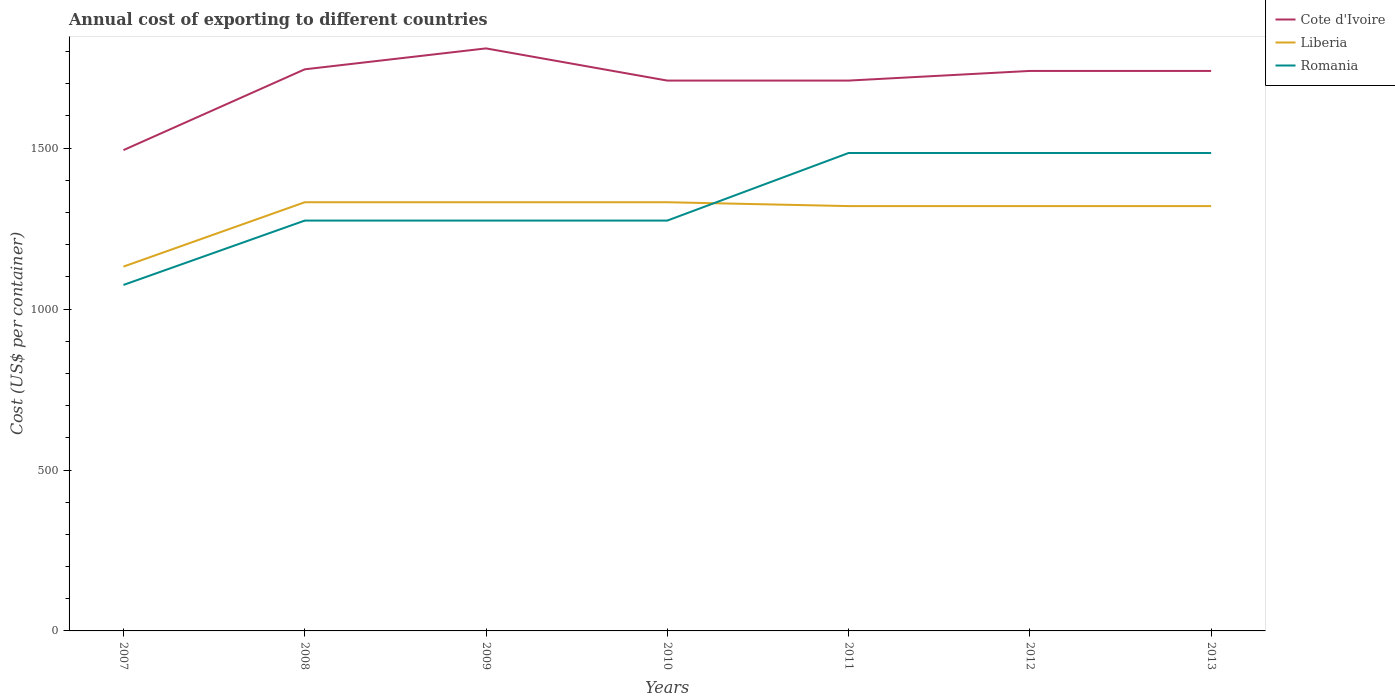How many different coloured lines are there?
Keep it short and to the point. 3. Does the line corresponding to Liberia intersect with the line corresponding to Romania?
Your response must be concise. Yes. Is the number of lines equal to the number of legend labels?
Your answer should be compact. Yes. Across all years, what is the maximum total annual cost of exporting in Liberia?
Keep it short and to the point. 1132. What is the total total annual cost of exporting in Liberia in the graph?
Provide a succinct answer. 0. What is the difference between the highest and the second highest total annual cost of exporting in Cote d'Ivoire?
Provide a succinct answer. 316. Is the total annual cost of exporting in Cote d'Ivoire strictly greater than the total annual cost of exporting in Liberia over the years?
Make the answer very short. No. How many lines are there?
Offer a very short reply. 3. How many years are there in the graph?
Make the answer very short. 7. What is the difference between two consecutive major ticks on the Y-axis?
Provide a succinct answer. 500. What is the title of the graph?
Your response must be concise. Annual cost of exporting to different countries. What is the label or title of the X-axis?
Your answer should be compact. Years. What is the label or title of the Y-axis?
Make the answer very short. Cost (US$ per container). What is the Cost (US$ per container) in Cote d'Ivoire in 2007?
Provide a succinct answer. 1494. What is the Cost (US$ per container) of Liberia in 2007?
Make the answer very short. 1132. What is the Cost (US$ per container) of Romania in 2007?
Provide a succinct answer. 1075. What is the Cost (US$ per container) in Cote d'Ivoire in 2008?
Provide a succinct answer. 1745. What is the Cost (US$ per container) in Liberia in 2008?
Offer a very short reply. 1332. What is the Cost (US$ per container) in Romania in 2008?
Give a very brief answer. 1275. What is the Cost (US$ per container) of Cote d'Ivoire in 2009?
Your answer should be very brief. 1810. What is the Cost (US$ per container) in Liberia in 2009?
Offer a very short reply. 1332. What is the Cost (US$ per container) of Romania in 2009?
Keep it short and to the point. 1275. What is the Cost (US$ per container) of Cote d'Ivoire in 2010?
Provide a succinct answer. 1710. What is the Cost (US$ per container) in Liberia in 2010?
Provide a succinct answer. 1332. What is the Cost (US$ per container) of Romania in 2010?
Your response must be concise. 1275. What is the Cost (US$ per container) of Cote d'Ivoire in 2011?
Your answer should be compact. 1710. What is the Cost (US$ per container) of Liberia in 2011?
Ensure brevity in your answer.  1320. What is the Cost (US$ per container) in Romania in 2011?
Your response must be concise. 1485. What is the Cost (US$ per container) in Cote d'Ivoire in 2012?
Offer a terse response. 1740. What is the Cost (US$ per container) in Liberia in 2012?
Provide a succinct answer. 1320. What is the Cost (US$ per container) of Romania in 2012?
Your answer should be compact. 1485. What is the Cost (US$ per container) in Cote d'Ivoire in 2013?
Provide a short and direct response. 1740. What is the Cost (US$ per container) in Liberia in 2013?
Keep it short and to the point. 1320. What is the Cost (US$ per container) of Romania in 2013?
Keep it short and to the point. 1485. Across all years, what is the maximum Cost (US$ per container) of Cote d'Ivoire?
Your answer should be very brief. 1810. Across all years, what is the maximum Cost (US$ per container) of Liberia?
Ensure brevity in your answer.  1332. Across all years, what is the maximum Cost (US$ per container) of Romania?
Give a very brief answer. 1485. Across all years, what is the minimum Cost (US$ per container) in Cote d'Ivoire?
Provide a succinct answer. 1494. Across all years, what is the minimum Cost (US$ per container) of Liberia?
Your answer should be compact. 1132. Across all years, what is the minimum Cost (US$ per container) in Romania?
Give a very brief answer. 1075. What is the total Cost (US$ per container) in Cote d'Ivoire in the graph?
Your response must be concise. 1.19e+04. What is the total Cost (US$ per container) in Liberia in the graph?
Provide a succinct answer. 9088. What is the total Cost (US$ per container) of Romania in the graph?
Keep it short and to the point. 9355. What is the difference between the Cost (US$ per container) in Cote d'Ivoire in 2007 and that in 2008?
Give a very brief answer. -251. What is the difference between the Cost (US$ per container) of Liberia in 2007 and that in 2008?
Provide a succinct answer. -200. What is the difference between the Cost (US$ per container) of Romania in 2007 and that in 2008?
Give a very brief answer. -200. What is the difference between the Cost (US$ per container) of Cote d'Ivoire in 2007 and that in 2009?
Your answer should be very brief. -316. What is the difference between the Cost (US$ per container) of Liberia in 2007 and that in 2009?
Provide a short and direct response. -200. What is the difference between the Cost (US$ per container) in Romania in 2007 and that in 2009?
Provide a succinct answer. -200. What is the difference between the Cost (US$ per container) in Cote d'Ivoire in 2007 and that in 2010?
Keep it short and to the point. -216. What is the difference between the Cost (US$ per container) in Liberia in 2007 and that in 2010?
Offer a very short reply. -200. What is the difference between the Cost (US$ per container) in Romania in 2007 and that in 2010?
Your answer should be very brief. -200. What is the difference between the Cost (US$ per container) in Cote d'Ivoire in 2007 and that in 2011?
Your answer should be compact. -216. What is the difference between the Cost (US$ per container) of Liberia in 2007 and that in 2011?
Make the answer very short. -188. What is the difference between the Cost (US$ per container) of Romania in 2007 and that in 2011?
Offer a terse response. -410. What is the difference between the Cost (US$ per container) in Cote d'Ivoire in 2007 and that in 2012?
Give a very brief answer. -246. What is the difference between the Cost (US$ per container) in Liberia in 2007 and that in 2012?
Provide a succinct answer. -188. What is the difference between the Cost (US$ per container) of Romania in 2007 and that in 2012?
Ensure brevity in your answer.  -410. What is the difference between the Cost (US$ per container) of Cote d'Ivoire in 2007 and that in 2013?
Provide a short and direct response. -246. What is the difference between the Cost (US$ per container) of Liberia in 2007 and that in 2013?
Provide a succinct answer. -188. What is the difference between the Cost (US$ per container) in Romania in 2007 and that in 2013?
Your answer should be very brief. -410. What is the difference between the Cost (US$ per container) in Cote d'Ivoire in 2008 and that in 2009?
Keep it short and to the point. -65. What is the difference between the Cost (US$ per container) of Liberia in 2008 and that in 2009?
Keep it short and to the point. 0. What is the difference between the Cost (US$ per container) in Romania in 2008 and that in 2009?
Your response must be concise. 0. What is the difference between the Cost (US$ per container) in Liberia in 2008 and that in 2010?
Your answer should be compact. 0. What is the difference between the Cost (US$ per container) of Cote d'Ivoire in 2008 and that in 2011?
Ensure brevity in your answer.  35. What is the difference between the Cost (US$ per container) of Liberia in 2008 and that in 2011?
Keep it short and to the point. 12. What is the difference between the Cost (US$ per container) in Romania in 2008 and that in 2011?
Ensure brevity in your answer.  -210. What is the difference between the Cost (US$ per container) in Liberia in 2008 and that in 2012?
Your answer should be compact. 12. What is the difference between the Cost (US$ per container) of Romania in 2008 and that in 2012?
Your answer should be very brief. -210. What is the difference between the Cost (US$ per container) of Cote d'Ivoire in 2008 and that in 2013?
Your answer should be very brief. 5. What is the difference between the Cost (US$ per container) in Romania in 2008 and that in 2013?
Your response must be concise. -210. What is the difference between the Cost (US$ per container) of Cote d'Ivoire in 2009 and that in 2010?
Offer a very short reply. 100. What is the difference between the Cost (US$ per container) in Romania in 2009 and that in 2010?
Provide a short and direct response. 0. What is the difference between the Cost (US$ per container) in Liberia in 2009 and that in 2011?
Provide a succinct answer. 12. What is the difference between the Cost (US$ per container) in Romania in 2009 and that in 2011?
Your answer should be very brief. -210. What is the difference between the Cost (US$ per container) in Cote d'Ivoire in 2009 and that in 2012?
Your answer should be very brief. 70. What is the difference between the Cost (US$ per container) of Romania in 2009 and that in 2012?
Your answer should be compact. -210. What is the difference between the Cost (US$ per container) in Cote d'Ivoire in 2009 and that in 2013?
Provide a short and direct response. 70. What is the difference between the Cost (US$ per container) of Romania in 2009 and that in 2013?
Provide a short and direct response. -210. What is the difference between the Cost (US$ per container) of Cote d'Ivoire in 2010 and that in 2011?
Make the answer very short. 0. What is the difference between the Cost (US$ per container) of Liberia in 2010 and that in 2011?
Your response must be concise. 12. What is the difference between the Cost (US$ per container) in Romania in 2010 and that in 2011?
Your answer should be very brief. -210. What is the difference between the Cost (US$ per container) of Liberia in 2010 and that in 2012?
Ensure brevity in your answer.  12. What is the difference between the Cost (US$ per container) of Romania in 2010 and that in 2012?
Provide a succinct answer. -210. What is the difference between the Cost (US$ per container) in Romania in 2010 and that in 2013?
Your answer should be very brief. -210. What is the difference between the Cost (US$ per container) of Cote d'Ivoire in 2011 and that in 2012?
Your answer should be compact. -30. What is the difference between the Cost (US$ per container) in Romania in 2011 and that in 2012?
Offer a very short reply. 0. What is the difference between the Cost (US$ per container) of Liberia in 2011 and that in 2013?
Provide a short and direct response. 0. What is the difference between the Cost (US$ per container) in Liberia in 2012 and that in 2013?
Your answer should be very brief. 0. What is the difference between the Cost (US$ per container) in Romania in 2012 and that in 2013?
Ensure brevity in your answer.  0. What is the difference between the Cost (US$ per container) of Cote d'Ivoire in 2007 and the Cost (US$ per container) of Liberia in 2008?
Offer a very short reply. 162. What is the difference between the Cost (US$ per container) in Cote d'Ivoire in 2007 and the Cost (US$ per container) in Romania in 2008?
Offer a very short reply. 219. What is the difference between the Cost (US$ per container) of Liberia in 2007 and the Cost (US$ per container) of Romania in 2008?
Your response must be concise. -143. What is the difference between the Cost (US$ per container) of Cote d'Ivoire in 2007 and the Cost (US$ per container) of Liberia in 2009?
Offer a very short reply. 162. What is the difference between the Cost (US$ per container) of Cote d'Ivoire in 2007 and the Cost (US$ per container) of Romania in 2009?
Provide a succinct answer. 219. What is the difference between the Cost (US$ per container) of Liberia in 2007 and the Cost (US$ per container) of Romania in 2009?
Make the answer very short. -143. What is the difference between the Cost (US$ per container) in Cote d'Ivoire in 2007 and the Cost (US$ per container) in Liberia in 2010?
Keep it short and to the point. 162. What is the difference between the Cost (US$ per container) in Cote d'Ivoire in 2007 and the Cost (US$ per container) in Romania in 2010?
Give a very brief answer. 219. What is the difference between the Cost (US$ per container) of Liberia in 2007 and the Cost (US$ per container) of Romania in 2010?
Provide a short and direct response. -143. What is the difference between the Cost (US$ per container) in Cote d'Ivoire in 2007 and the Cost (US$ per container) in Liberia in 2011?
Your answer should be very brief. 174. What is the difference between the Cost (US$ per container) in Liberia in 2007 and the Cost (US$ per container) in Romania in 2011?
Offer a very short reply. -353. What is the difference between the Cost (US$ per container) in Cote d'Ivoire in 2007 and the Cost (US$ per container) in Liberia in 2012?
Your response must be concise. 174. What is the difference between the Cost (US$ per container) of Liberia in 2007 and the Cost (US$ per container) of Romania in 2012?
Provide a short and direct response. -353. What is the difference between the Cost (US$ per container) of Cote d'Ivoire in 2007 and the Cost (US$ per container) of Liberia in 2013?
Your answer should be very brief. 174. What is the difference between the Cost (US$ per container) in Cote d'Ivoire in 2007 and the Cost (US$ per container) in Romania in 2013?
Your answer should be very brief. 9. What is the difference between the Cost (US$ per container) in Liberia in 2007 and the Cost (US$ per container) in Romania in 2013?
Give a very brief answer. -353. What is the difference between the Cost (US$ per container) of Cote d'Ivoire in 2008 and the Cost (US$ per container) of Liberia in 2009?
Your answer should be compact. 413. What is the difference between the Cost (US$ per container) of Cote d'Ivoire in 2008 and the Cost (US$ per container) of Romania in 2009?
Your response must be concise. 470. What is the difference between the Cost (US$ per container) in Liberia in 2008 and the Cost (US$ per container) in Romania in 2009?
Make the answer very short. 57. What is the difference between the Cost (US$ per container) of Cote d'Ivoire in 2008 and the Cost (US$ per container) of Liberia in 2010?
Ensure brevity in your answer.  413. What is the difference between the Cost (US$ per container) of Cote d'Ivoire in 2008 and the Cost (US$ per container) of Romania in 2010?
Keep it short and to the point. 470. What is the difference between the Cost (US$ per container) in Cote d'Ivoire in 2008 and the Cost (US$ per container) in Liberia in 2011?
Your answer should be compact. 425. What is the difference between the Cost (US$ per container) of Cote d'Ivoire in 2008 and the Cost (US$ per container) of Romania in 2011?
Provide a succinct answer. 260. What is the difference between the Cost (US$ per container) in Liberia in 2008 and the Cost (US$ per container) in Romania in 2011?
Your answer should be very brief. -153. What is the difference between the Cost (US$ per container) of Cote d'Ivoire in 2008 and the Cost (US$ per container) of Liberia in 2012?
Offer a terse response. 425. What is the difference between the Cost (US$ per container) in Cote d'Ivoire in 2008 and the Cost (US$ per container) in Romania in 2012?
Provide a succinct answer. 260. What is the difference between the Cost (US$ per container) of Liberia in 2008 and the Cost (US$ per container) of Romania in 2012?
Offer a very short reply. -153. What is the difference between the Cost (US$ per container) in Cote d'Ivoire in 2008 and the Cost (US$ per container) in Liberia in 2013?
Keep it short and to the point. 425. What is the difference between the Cost (US$ per container) of Cote d'Ivoire in 2008 and the Cost (US$ per container) of Romania in 2013?
Keep it short and to the point. 260. What is the difference between the Cost (US$ per container) in Liberia in 2008 and the Cost (US$ per container) in Romania in 2013?
Make the answer very short. -153. What is the difference between the Cost (US$ per container) in Cote d'Ivoire in 2009 and the Cost (US$ per container) in Liberia in 2010?
Provide a short and direct response. 478. What is the difference between the Cost (US$ per container) in Cote d'Ivoire in 2009 and the Cost (US$ per container) in Romania in 2010?
Offer a terse response. 535. What is the difference between the Cost (US$ per container) in Cote d'Ivoire in 2009 and the Cost (US$ per container) in Liberia in 2011?
Provide a succinct answer. 490. What is the difference between the Cost (US$ per container) of Cote d'Ivoire in 2009 and the Cost (US$ per container) of Romania in 2011?
Offer a very short reply. 325. What is the difference between the Cost (US$ per container) of Liberia in 2009 and the Cost (US$ per container) of Romania in 2011?
Keep it short and to the point. -153. What is the difference between the Cost (US$ per container) in Cote d'Ivoire in 2009 and the Cost (US$ per container) in Liberia in 2012?
Give a very brief answer. 490. What is the difference between the Cost (US$ per container) in Cote d'Ivoire in 2009 and the Cost (US$ per container) in Romania in 2012?
Your response must be concise. 325. What is the difference between the Cost (US$ per container) of Liberia in 2009 and the Cost (US$ per container) of Romania in 2012?
Offer a terse response. -153. What is the difference between the Cost (US$ per container) of Cote d'Ivoire in 2009 and the Cost (US$ per container) of Liberia in 2013?
Your answer should be very brief. 490. What is the difference between the Cost (US$ per container) in Cote d'Ivoire in 2009 and the Cost (US$ per container) in Romania in 2013?
Keep it short and to the point. 325. What is the difference between the Cost (US$ per container) of Liberia in 2009 and the Cost (US$ per container) of Romania in 2013?
Your response must be concise. -153. What is the difference between the Cost (US$ per container) in Cote d'Ivoire in 2010 and the Cost (US$ per container) in Liberia in 2011?
Give a very brief answer. 390. What is the difference between the Cost (US$ per container) in Cote d'Ivoire in 2010 and the Cost (US$ per container) in Romania in 2011?
Your response must be concise. 225. What is the difference between the Cost (US$ per container) in Liberia in 2010 and the Cost (US$ per container) in Romania in 2011?
Keep it short and to the point. -153. What is the difference between the Cost (US$ per container) of Cote d'Ivoire in 2010 and the Cost (US$ per container) of Liberia in 2012?
Provide a succinct answer. 390. What is the difference between the Cost (US$ per container) of Cote d'Ivoire in 2010 and the Cost (US$ per container) of Romania in 2012?
Give a very brief answer. 225. What is the difference between the Cost (US$ per container) in Liberia in 2010 and the Cost (US$ per container) in Romania in 2012?
Your answer should be very brief. -153. What is the difference between the Cost (US$ per container) in Cote d'Ivoire in 2010 and the Cost (US$ per container) in Liberia in 2013?
Keep it short and to the point. 390. What is the difference between the Cost (US$ per container) in Cote d'Ivoire in 2010 and the Cost (US$ per container) in Romania in 2013?
Your answer should be compact. 225. What is the difference between the Cost (US$ per container) of Liberia in 2010 and the Cost (US$ per container) of Romania in 2013?
Your response must be concise. -153. What is the difference between the Cost (US$ per container) in Cote d'Ivoire in 2011 and the Cost (US$ per container) in Liberia in 2012?
Ensure brevity in your answer.  390. What is the difference between the Cost (US$ per container) of Cote d'Ivoire in 2011 and the Cost (US$ per container) of Romania in 2012?
Keep it short and to the point. 225. What is the difference between the Cost (US$ per container) in Liberia in 2011 and the Cost (US$ per container) in Romania in 2012?
Ensure brevity in your answer.  -165. What is the difference between the Cost (US$ per container) of Cote d'Ivoire in 2011 and the Cost (US$ per container) of Liberia in 2013?
Offer a terse response. 390. What is the difference between the Cost (US$ per container) of Cote d'Ivoire in 2011 and the Cost (US$ per container) of Romania in 2013?
Offer a very short reply. 225. What is the difference between the Cost (US$ per container) in Liberia in 2011 and the Cost (US$ per container) in Romania in 2013?
Offer a very short reply. -165. What is the difference between the Cost (US$ per container) in Cote d'Ivoire in 2012 and the Cost (US$ per container) in Liberia in 2013?
Provide a succinct answer. 420. What is the difference between the Cost (US$ per container) in Cote d'Ivoire in 2012 and the Cost (US$ per container) in Romania in 2013?
Your answer should be very brief. 255. What is the difference between the Cost (US$ per container) of Liberia in 2012 and the Cost (US$ per container) of Romania in 2013?
Offer a terse response. -165. What is the average Cost (US$ per container) in Cote d'Ivoire per year?
Offer a terse response. 1707. What is the average Cost (US$ per container) of Liberia per year?
Make the answer very short. 1298.29. What is the average Cost (US$ per container) of Romania per year?
Provide a succinct answer. 1336.43. In the year 2007, what is the difference between the Cost (US$ per container) in Cote d'Ivoire and Cost (US$ per container) in Liberia?
Keep it short and to the point. 362. In the year 2007, what is the difference between the Cost (US$ per container) of Cote d'Ivoire and Cost (US$ per container) of Romania?
Make the answer very short. 419. In the year 2008, what is the difference between the Cost (US$ per container) in Cote d'Ivoire and Cost (US$ per container) in Liberia?
Provide a succinct answer. 413. In the year 2008, what is the difference between the Cost (US$ per container) of Cote d'Ivoire and Cost (US$ per container) of Romania?
Your answer should be compact. 470. In the year 2009, what is the difference between the Cost (US$ per container) of Cote d'Ivoire and Cost (US$ per container) of Liberia?
Your answer should be very brief. 478. In the year 2009, what is the difference between the Cost (US$ per container) of Cote d'Ivoire and Cost (US$ per container) of Romania?
Provide a succinct answer. 535. In the year 2010, what is the difference between the Cost (US$ per container) of Cote d'Ivoire and Cost (US$ per container) of Liberia?
Provide a short and direct response. 378. In the year 2010, what is the difference between the Cost (US$ per container) in Cote d'Ivoire and Cost (US$ per container) in Romania?
Ensure brevity in your answer.  435. In the year 2011, what is the difference between the Cost (US$ per container) in Cote d'Ivoire and Cost (US$ per container) in Liberia?
Your answer should be compact. 390. In the year 2011, what is the difference between the Cost (US$ per container) in Cote d'Ivoire and Cost (US$ per container) in Romania?
Provide a short and direct response. 225. In the year 2011, what is the difference between the Cost (US$ per container) in Liberia and Cost (US$ per container) in Romania?
Keep it short and to the point. -165. In the year 2012, what is the difference between the Cost (US$ per container) of Cote d'Ivoire and Cost (US$ per container) of Liberia?
Provide a short and direct response. 420. In the year 2012, what is the difference between the Cost (US$ per container) of Cote d'Ivoire and Cost (US$ per container) of Romania?
Provide a succinct answer. 255. In the year 2012, what is the difference between the Cost (US$ per container) in Liberia and Cost (US$ per container) in Romania?
Your answer should be very brief. -165. In the year 2013, what is the difference between the Cost (US$ per container) in Cote d'Ivoire and Cost (US$ per container) in Liberia?
Provide a short and direct response. 420. In the year 2013, what is the difference between the Cost (US$ per container) of Cote d'Ivoire and Cost (US$ per container) of Romania?
Your answer should be compact. 255. In the year 2013, what is the difference between the Cost (US$ per container) in Liberia and Cost (US$ per container) in Romania?
Your answer should be compact. -165. What is the ratio of the Cost (US$ per container) of Cote d'Ivoire in 2007 to that in 2008?
Keep it short and to the point. 0.86. What is the ratio of the Cost (US$ per container) of Liberia in 2007 to that in 2008?
Ensure brevity in your answer.  0.85. What is the ratio of the Cost (US$ per container) in Romania in 2007 to that in 2008?
Provide a succinct answer. 0.84. What is the ratio of the Cost (US$ per container) of Cote d'Ivoire in 2007 to that in 2009?
Provide a succinct answer. 0.83. What is the ratio of the Cost (US$ per container) of Liberia in 2007 to that in 2009?
Provide a short and direct response. 0.85. What is the ratio of the Cost (US$ per container) in Romania in 2007 to that in 2009?
Your answer should be compact. 0.84. What is the ratio of the Cost (US$ per container) in Cote d'Ivoire in 2007 to that in 2010?
Offer a terse response. 0.87. What is the ratio of the Cost (US$ per container) in Liberia in 2007 to that in 2010?
Your answer should be very brief. 0.85. What is the ratio of the Cost (US$ per container) of Romania in 2007 to that in 2010?
Provide a succinct answer. 0.84. What is the ratio of the Cost (US$ per container) of Cote d'Ivoire in 2007 to that in 2011?
Your answer should be compact. 0.87. What is the ratio of the Cost (US$ per container) of Liberia in 2007 to that in 2011?
Keep it short and to the point. 0.86. What is the ratio of the Cost (US$ per container) of Romania in 2007 to that in 2011?
Give a very brief answer. 0.72. What is the ratio of the Cost (US$ per container) in Cote d'Ivoire in 2007 to that in 2012?
Your answer should be compact. 0.86. What is the ratio of the Cost (US$ per container) of Liberia in 2007 to that in 2012?
Keep it short and to the point. 0.86. What is the ratio of the Cost (US$ per container) of Romania in 2007 to that in 2012?
Your answer should be compact. 0.72. What is the ratio of the Cost (US$ per container) of Cote d'Ivoire in 2007 to that in 2013?
Keep it short and to the point. 0.86. What is the ratio of the Cost (US$ per container) in Liberia in 2007 to that in 2013?
Make the answer very short. 0.86. What is the ratio of the Cost (US$ per container) in Romania in 2007 to that in 2013?
Give a very brief answer. 0.72. What is the ratio of the Cost (US$ per container) of Cote d'Ivoire in 2008 to that in 2009?
Your answer should be compact. 0.96. What is the ratio of the Cost (US$ per container) of Liberia in 2008 to that in 2009?
Ensure brevity in your answer.  1. What is the ratio of the Cost (US$ per container) of Cote d'Ivoire in 2008 to that in 2010?
Keep it short and to the point. 1.02. What is the ratio of the Cost (US$ per container) of Romania in 2008 to that in 2010?
Provide a succinct answer. 1. What is the ratio of the Cost (US$ per container) of Cote d'Ivoire in 2008 to that in 2011?
Provide a short and direct response. 1.02. What is the ratio of the Cost (US$ per container) in Liberia in 2008 to that in 2011?
Your response must be concise. 1.01. What is the ratio of the Cost (US$ per container) of Romania in 2008 to that in 2011?
Your response must be concise. 0.86. What is the ratio of the Cost (US$ per container) in Cote d'Ivoire in 2008 to that in 2012?
Offer a terse response. 1. What is the ratio of the Cost (US$ per container) of Liberia in 2008 to that in 2012?
Ensure brevity in your answer.  1.01. What is the ratio of the Cost (US$ per container) in Romania in 2008 to that in 2012?
Offer a terse response. 0.86. What is the ratio of the Cost (US$ per container) in Liberia in 2008 to that in 2013?
Offer a very short reply. 1.01. What is the ratio of the Cost (US$ per container) in Romania in 2008 to that in 2013?
Provide a succinct answer. 0.86. What is the ratio of the Cost (US$ per container) in Cote d'Ivoire in 2009 to that in 2010?
Ensure brevity in your answer.  1.06. What is the ratio of the Cost (US$ per container) of Cote d'Ivoire in 2009 to that in 2011?
Your answer should be very brief. 1.06. What is the ratio of the Cost (US$ per container) in Liberia in 2009 to that in 2011?
Give a very brief answer. 1.01. What is the ratio of the Cost (US$ per container) in Romania in 2009 to that in 2011?
Your answer should be compact. 0.86. What is the ratio of the Cost (US$ per container) in Cote d'Ivoire in 2009 to that in 2012?
Offer a terse response. 1.04. What is the ratio of the Cost (US$ per container) in Liberia in 2009 to that in 2012?
Provide a short and direct response. 1.01. What is the ratio of the Cost (US$ per container) of Romania in 2009 to that in 2012?
Provide a succinct answer. 0.86. What is the ratio of the Cost (US$ per container) of Cote d'Ivoire in 2009 to that in 2013?
Your response must be concise. 1.04. What is the ratio of the Cost (US$ per container) of Liberia in 2009 to that in 2013?
Make the answer very short. 1.01. What is the ratio of the Cost (US$ per container) of Romania in 2009 to that in 2013?
Offer a very short reply. 0.86. What is the ratio of the Cost (US$ per container) of Liberia in 2010 to that in 2011?
Offer a terse response. 1.01. What is the ratio of the Cost (US$ per container) of Romania in 2010 to that in 2011?
Your answer should be compact. 0.86. What is the ratio of the Cost (US$ per container) in Cote d'Ivoire in 2010 to that in 2012?
Offer a terse response. 0.98. What is the ratio of the Cost (US$ per container) in Liberia in 2010 to that in 2012?
Your response must be concise. 1.01. What is the ratio of the Cost (US$ per container) in Romania in 2010 to that in 2012?
Your response must be concise. 0.86. What is the ratio of the Cost (US$ per container) of Cote d'Ivoire in 2010 to that in 2013?
Keep it short and to the point. 0.98. What is the ratio of the Cost (US$ per container) in Liberia in 2010 to that in 2013?
Offer a very short reply. 1.01. What is the ratio of the Cost (US$ per container) of Romania in 2010 to that in 2013?
Offer a terse response. 0.86. What is the ratio of the Cost (US$ per container) in Cote d'Ivoire in 2011 to that in 2012?
Keep it short and to the point. 0.98. What is the ratio of the Cost (US$ per container) of Liberia in 2011 to that in 2012?
Your answer should be very brief. 1. What is the ratio of the Cost (US$ per container) in Cote d'Ivoire in 2011 to that in 2013?
Make the answer very short. 0.98. What is the ratio of the Cost (US$ per container) in Romania in 2011 to that in 2013?
Your answer should be very brief. 1. What is the ratio of the Cost (US$ per container) in Cote d'Ivoire in 2012 to that in 2013?
Offer a very short reply. 1. What is the difference between the highest and the second highest Cost (US$ per container) in Cote d'Ivoire?
Keep it short and to the point. 65. What is the difference between the highest and the second highest Cost (US$ per container) of Romania?
Offer a terse response. 0. What is the difference between the highest and the lowest Cost (US$ per container) of Cote d'Ivoire?
Make the answer very short. 316. What is the difference between the highest and the lowest Cost (US$ per container) of Liberia?
Your answer should be very brief. 200. What is the difference between the highest and the lowest Cost (US$ per container) of Romania?
Make the answer very short. 410. 